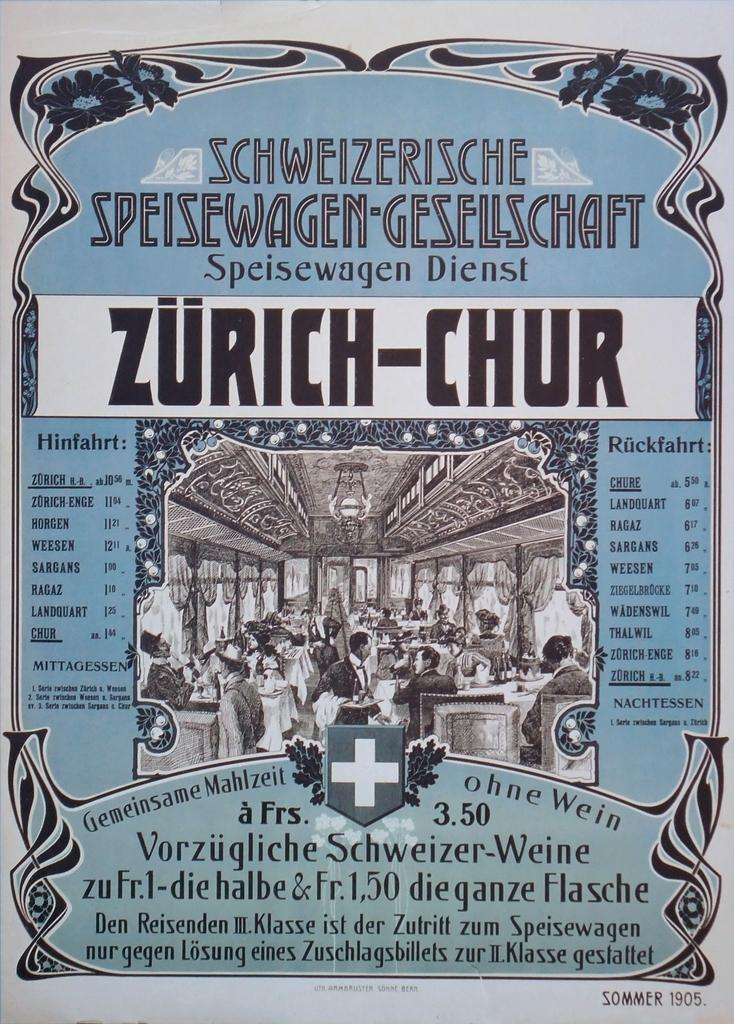<image>
Share a concise interpretation of the image provided. a blue and white poster and words Zurich-Chur on it 